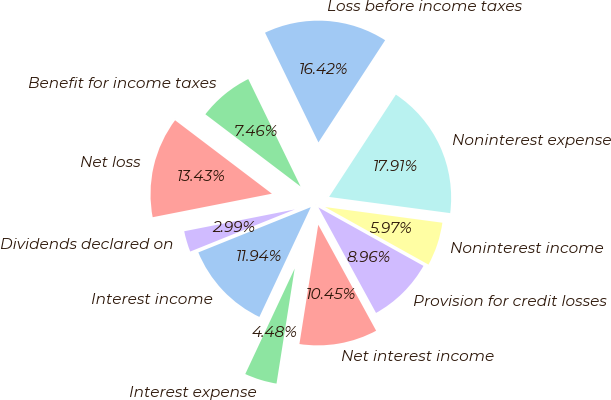Convert chart to OTSL. <chart><loc_0><loc_0><loc_500><loc_500><pie_chart><fcel>Interest income<fcel>Interest expense<fcel>Net interest income<fcel>Provision for credit losses<fcel>Noninterest income<fcel>Noninterest expense<fcel>Loss before income taxes<fcel>Benefit for income taxes<fcel>Net loss<fcel>Dividends declared on<nl><fcel>11.94%<fcel>4.48%<fcel>10.45%<fcel>8.96%<fcel>5.97%<fcel>17.91%<fcel>16.42%<fcel>7.46%<fcel>13.43%<fcel>2.99%<nl></chart> 